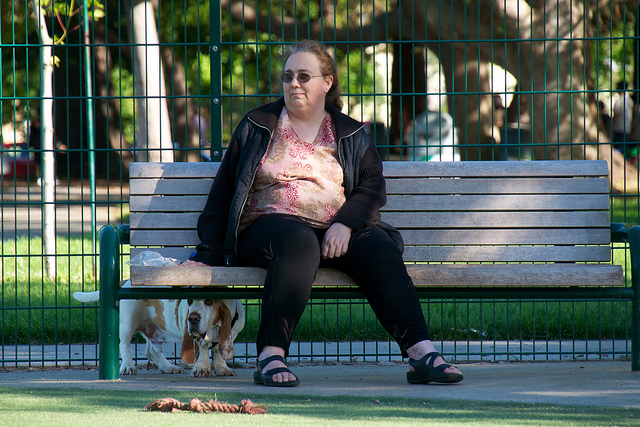What is the woman doing in the park? The woman appears to be taking a moment to rest on a park bench. She seems to be watching over her dog, a Basset Hound, which is on the ground behind the fence, likely in a designated dog play area. What time of day does it seem to be in the image? Based on the shadows and the quality of the light, it appears to be either late afternoon or early evening, a common time for people to visit parks for leisure activities or to walk their dogs. 